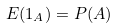<formula> <loc_0><loc_0><loc_500><loc_500>E ( 1 _ { A } ) = P ( A )</formula> 